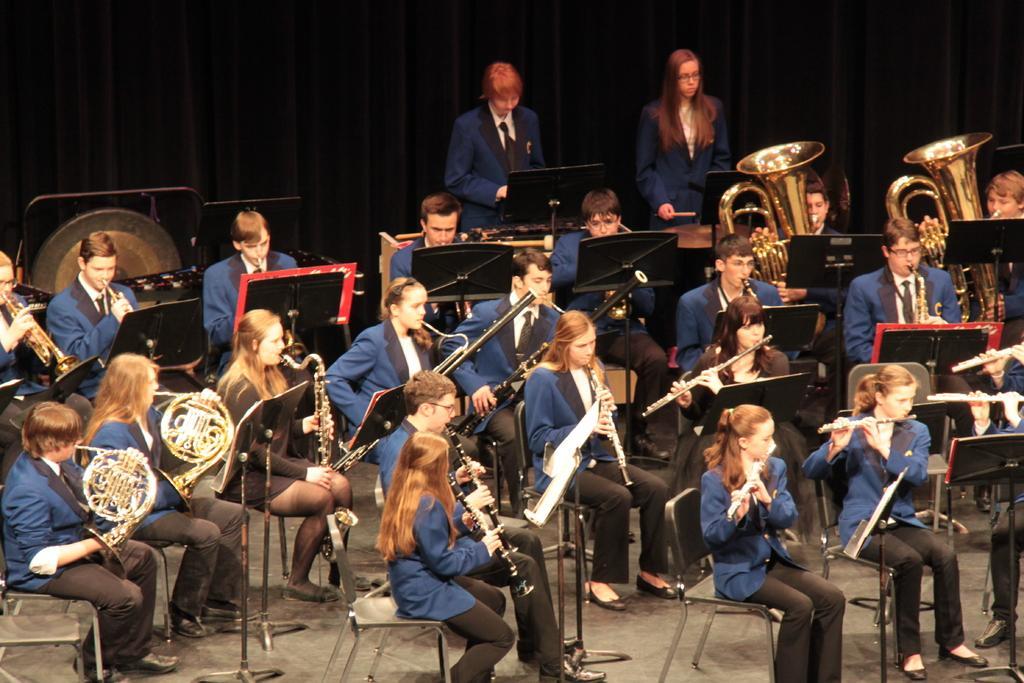Please provide a concise description of this image. In this image we can see a group of people sitting on a chair. They are wearing a suit and a tie. They are playing musical instruments. Here we can see two persons standing on the floor. In the background, we can see the black curtain. 